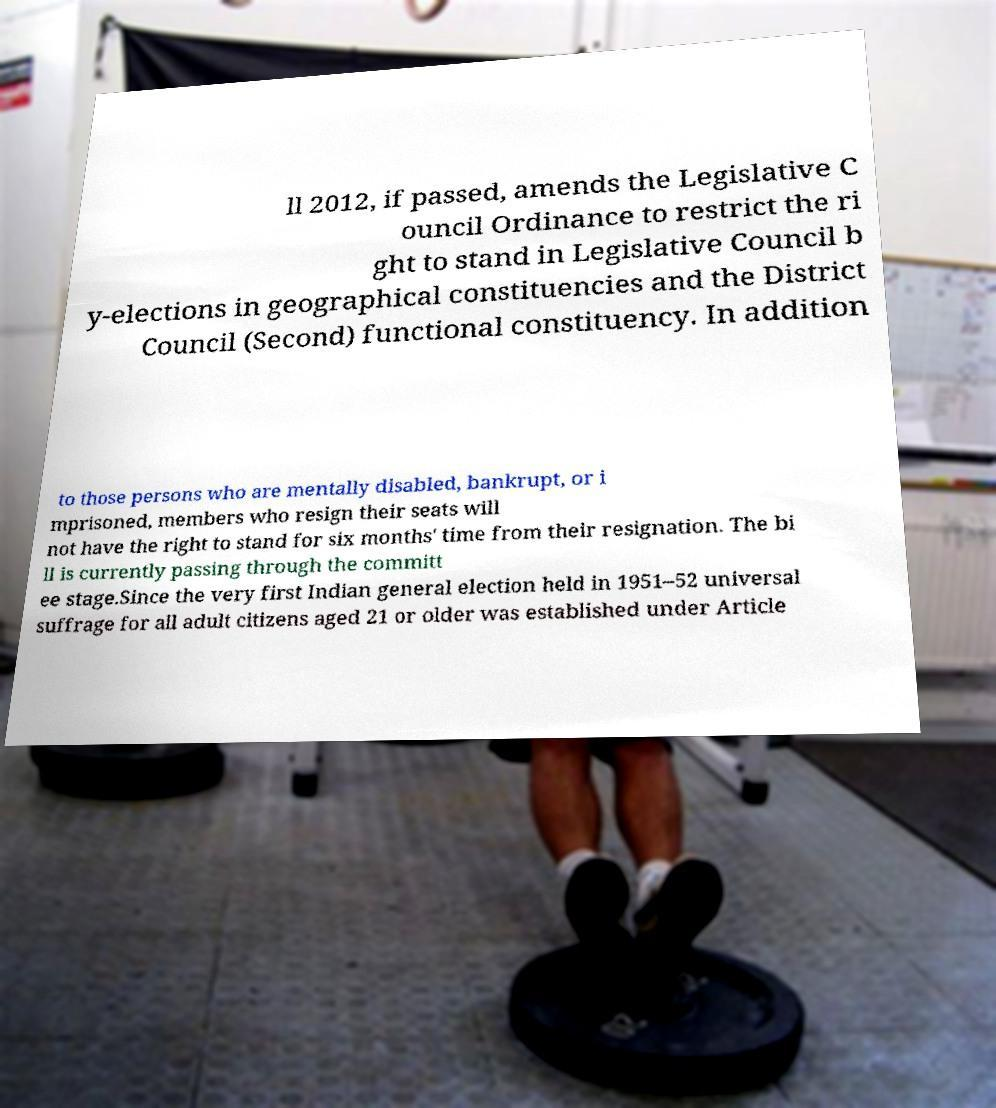There's text embedded in this image that I need extracted. Can you transcribe it verbatim? ll 2012, if passed, amends the Legislative C ouncil Ordinance to restrict the ri ght to stand in Legislative Council b y-elections in geographical constituencies and the District Council (Second) functional constituency. In addition to those persons who are mentally disabled, bankrupt, or i mprisoned, members who resign their seats will not have the right to stand for six months' time from their resignation. The bi ll is currently passing through the committ ee stage.Since the very first Indian general election held in 1951–52 universal suffrage for all adult citizens aged 21 or older was established under Article 